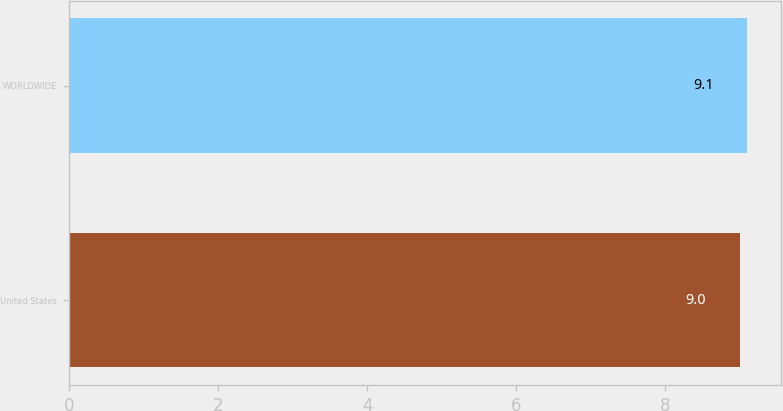Convert chart. <chart><loc_0><loc_0><loc_500><loc_500><bar_chart><fcel>United States<fcel>WORLDWIDE<nl><fcel>9<fcel>9.1<nl></chart> 